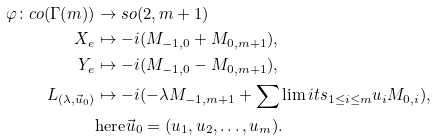<formula> <loc_0><loc_0><loc_500><loc_500>\varphi \colon c o ( \Gamma ( m ) ) & \rightarrow s o ( 2 , m + 1 ) \\ X _ { e } & \mapsto - i ( M _ { - 1 , 0 } + M _ { 0 , m + 1 } ) , \\ Y _ { e } & \mapsto - i ( M _ { - 1 , 0 } - M _ { 0 , m + 1 } ) , \\ L _ { ( \lambda , \vec { u } _ { 0 } ) } & \mapsto - i ( - \lambda M _ { - 1 , m + 1 } + \sum \lim i t s _ { 1 \leq i \leq m } u _ { i } M _ { 0 , i } ) , \\ & \text {here} \vec { u } _ { 0 } = ( u _ { 1 } , u _ { 2 } , \dots , u _ { m } ) .</formula> 